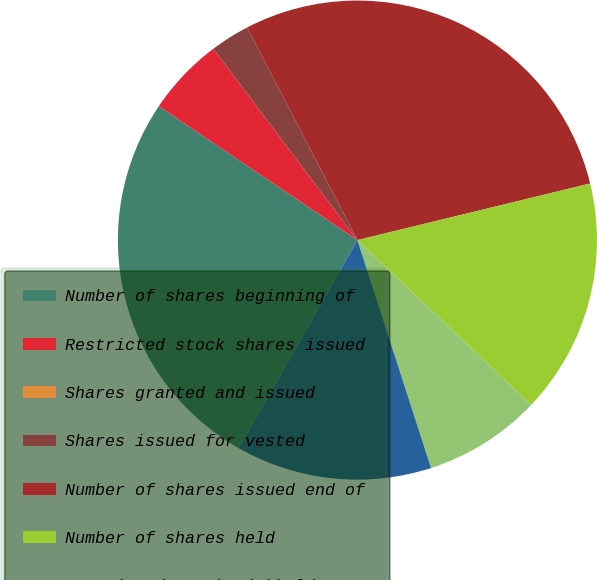Convert chart. <chart><loc_0><loc_0><loc_500><loc_500><pie_chart><fcel>Number of shares beginning of<fcel>Restricted stock shares issued<fcel>Shares granted and issued<fcel>Shares issued for vested<fcel>Number of shares issued end of<fcel>Number of shares held<fcel>Restricted stock withheld or<fcel>Number of shares held end of<nl><fcel>26.18%<fcel>5.29%<fcel>0.0%<fcel>2.65%<fcel>28.82%<fcel>15.88%<fcel>7.94%<fcel>13.23%<nl></chart> 